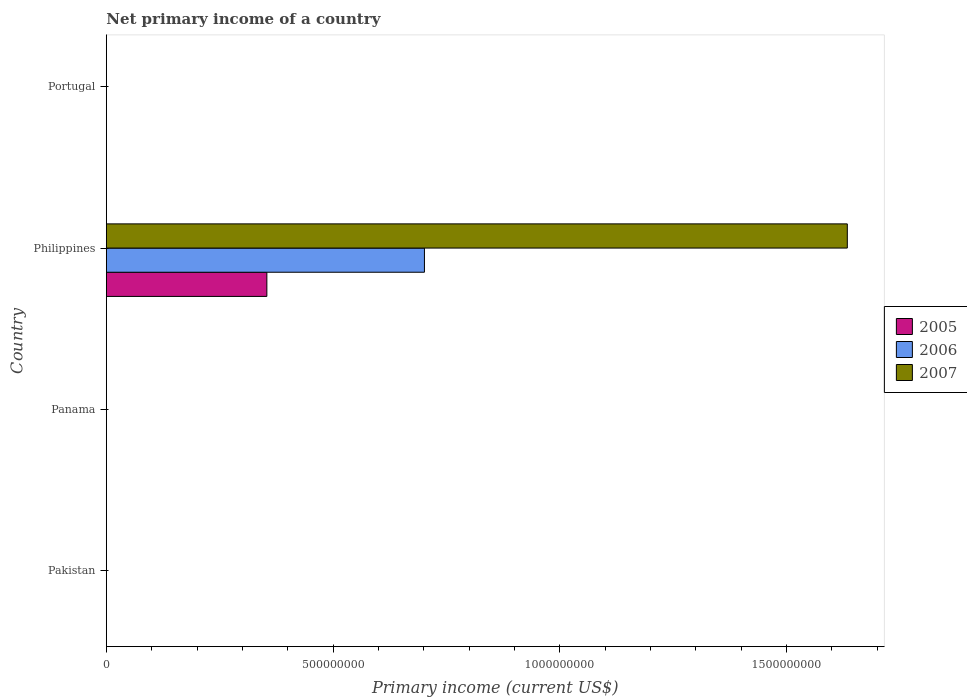How many different coloured bars are there?
Give a very brief answer. 3. Are the number of bars per tick equal to the number of legend labels?
Provide a succinct answer. No. Are the number of bars on each tick of the Y-axis equal?
Your answer should be very brief. No. How many bars are there on the 4th tick from the top?
Ensure brevity in your answer.  0. How many bars are there on the 3rd tick from the bottom?
Ensure brevity in your answer.  3. What is the label of the 3rd group of bars from the top?
Offer a terse response. Panama. What is the primary income in 2007 in Philippines?
Your answer should be very brief. 1.63e+09. Across all countries, what is the maximum primary income in 2007?
Give a very brief answer. 1.63e+09. What is the total primary income in 2006 in the graph?
Provide a succinct answer. 7.02e+08. What is the difference between the primary income in 2007 in Panama and the primary income in 2006 in Philippines?
Give a very brief answer. -7.02e+08. What is the average primary income in 2006 per country?
Provide a succinct answer. 1.75e+08. What is the difference between the primary income in 2007 and primary income in 2006 in Philippines?
Your answer should be very brief. 9.33e+08. In how many countries, is the primary income in 2005 greater than 1600000000 US$?
Provide a succinct answer. 0. What is the difference between the highest and the lowest primary income in 2005?
Offer a terse response. 3.54e+08. In how many countries, is the primary income in 2007 greater than the average primary income in 2007 taken over all countries?
Make the answer very short. 1. Is it the case that in every country, the sum of the primary income in 2006 and primary income in 2005 is greater than the primary income in 2007?
Provide a succinct answer. No. Are the values on the major ticks of X-axis written in scientific E-notation?
Make the answer very short. No. Does the graph contain grids?
Offer a terse response. No. How many legend labels are there?
Your answer should be compact. 3. How are the legend labels stacked?
Provide a short and direct response. Vertical. What is the title of the graph?
Your answer should be compact. Net primary income of a country. Does "1961" appear as one of the legend labels in the graph?
Offer a terse response. No. What is the label or title of the X-axis?
Ensure brevity in your answer.  Primary income (current US$). What is the label or title of the Y-axis?
Your response must be concise. Country. What is the Primary income (current US$) in 2006 in Pakistan?
Your answer should be compact. 0. What is the Primary income (current US$) of 2006 in Panama?
Ensure brevity in your answer.  0. What is the Primary income (current US$) of 2007 in Panama?
Offer a very short reply. 0. What is the Primary income (current US$) of 2005 in Philippines?
Your response must be concise. 3.54e+08. What is the Primary income (current US$) in 2006 in Philippines?
Give a very brief answer. 7.02e+08. What is the Primary income (current US$) in 2007 in Philippines?
Make the answer very short. 1.63e+09. What is the Primary income (current US$) in 2005 in Portugal?
Give a very brief answer. 0. What is the Primary income (current US$) of 2006 in Portugal?
Offer a very short reply. 0. Across all countries, what is the maximum Primary income (current US$) of 2005?
Ensure brevity in your answer.  3.54e+08. Across all countries, what is the maximum Primary income (current US$) in 2006?
Make the answer very short. 7.02e+08. Across all countries, what is the maximum Primary income (current US$) of 2007?
Give a very brief answer. 1.63e+09. What is the total Primary income (current US$) of 2005 in the graph?
Keep it short and to the point. 3.54e+08. What is the total Primary income (current US$) in 2006 in the graph?
Provide a succinct answer. 7.02e+08. What is the total Primary income (current US$) in 2007 in the graph?
Give a very brief answer. 1.63e+09. What is the average Primary income (current US$) of 2005 per country?
Offer a very short reply. 8.85e+07. What is the average Primary income (current US$) of 2006 per country?
Offer a terse response. 1.75e+08. What is the average Primary income (current US$) of 2007 per country?
Give a very brief answer. 4.09e+08. What is the difference between the Primary income (current US$) in 2005 and Primary income (current US$) in 2006 in Philippines?
Your response must be concise. -3.48e+08. What is the difference between the Primary income (current US$) in 2005 and Primary income (current US$) in 2007 in Philippines?
Make the answer very short. -1.28e+09. What is the difference between the Primary income (current US$) of 2006 and Primary income (current US$) of 2007 in Philippines?
Give a very brief answer. -9.33e+08. What is the difference between the highest and the lowest Primary income (current US$) of 2005?
Your answer should be very brief. 3.54e+08. What is the difference between the highest and the lowest Primary income (current US$) in 2006?
Your answer should be compact. 7.02e+08. What is the difference between the highest and the lowest Primary income (current US$) in 2007?
Your answer should be compact. 1.63e+09. 